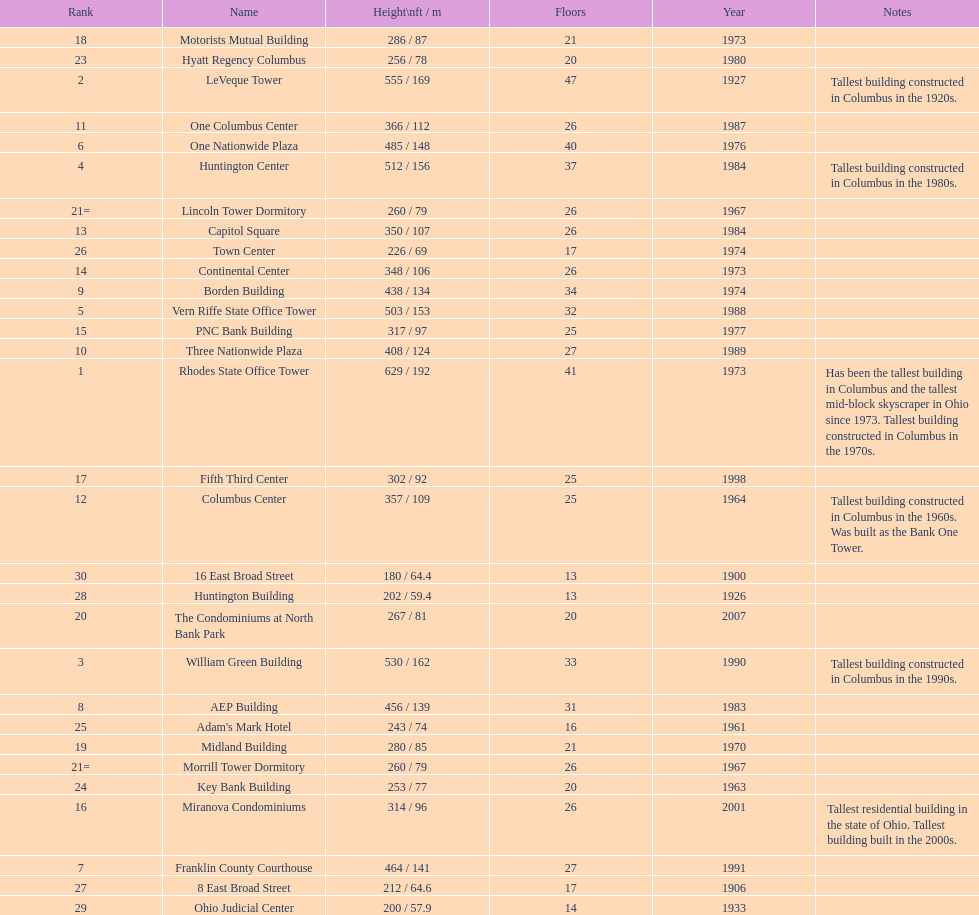Which buildings are taller than 500 ft? Rhodes State Office Tower, LeVeque Tower, William Green Building, Huntington Center, Vern Riffe State Office Tower. Could you parse the entire table as a dict? {'header': ['Rank', 'Name', 'Height\\nft / m', 'Floors', 'Year', 'Notes'], 'rows': [['18', 'Motorists Mutual Building', '286 / 87', '21', '1973', ''], ['23', 'Hyatt Regency Columbus', '256 / 78', '20', '1980', ''], ['2', 'LeVeque Tower', '555 / 169', '47', '1927', 'Tallest building constructed in Columbus in the 1920s.'], ['11', 'One Columbus Center', '366 / 112', '26', '1987', ''], ['6', 'One Nationwide Plaza', '485 / 148', '40', '1976', ''], ['4', 'Huntington Center', '512 / 156', '37', '1984', 'Tallest building constructed in Columbus in the 1980s.'], ['21=', 'Lincoln Tower Dormitory', '260 / 79', '26', '1967', ''], ['13', 'Capitol Square', '350 / 107', '26', '1984', ''], ['26', 'Town Center', '226 / 69', '17', '1974', ''], ['14', 'Continental Center', '348 / 106', '26', '1973', ''], ['9', 'Borden Building', '438 / 134', '34', '1974', ''], ['5', 'Vern Riffe State Office Tower', '503 / 153', '32', '1988', ''], ['15', 'PNC Bank Building', '317 / 97', '25', '1977', ''], ['10', 'Three Nationwide Plaza', '408 / 124', '27', '1989', ''], ['1', 'Rhodes State Office Tower', '629 / 192', '41', '1973', 'Has been the tallest building in Columbus and the tallest mid-block skyscraper in Ohio since 1973. Tallest building constructed in Columbus in the 1970s.'], ['17', 'Fifth Third Center', '302 / 92', '25', '1998', ''], ['12', 'Columbus Center', '357 / 109', '25', '1964', 'Tallest building constructed in Columbus in the 1960s. Was built as the Bank One Tower.'], ['30', '16 East Broad Street', '180 / 64.4', '13', '1900', ''], ['28', 'Huntington Building', '202 / 59.4', '13', '1926', ''], ['20', 'The Condominiums at North Bank Park', '267 / 81', '20', '2007', ''], ['3', 'William Green Building', '530 / 162', '33', '1990', 'Tallest building constructed in Columbus in the 1990s.'], ['8', 'AEP Building', '456 / 139', '31', '1983', ''], ['25', "Adam's Mark Hotel", '243 / 74', '16', '1961', ''], ['19', 'Midland Building', '280 / 85', '21', '1970', ''], ['21=', 'Morrill Tower Dormitory', '260 / 79', '26', '1967', ''], ['24', 'Key Bank Building', '253 / 77', '20', '1963', ''], ['16', 'Miranova Condominiums', '314 / 96', '26', '2001', 'Tallest residential building in the state of Ohio. Tallest building built in the 2000s.'], ['7', 'Franklin County Courthouse', '464 / 141', '27', '1991', ''], ['27', '8 East Broad Street', '212 / 64.6', '17', '1906', ''], ['29', 'Ohio Judicial Center', '200 / 57.9', '14', '1933', '']]} 